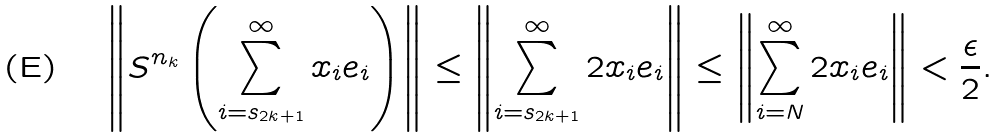Convert formula to latex. <formula><loc_0><loc_0><loc_500><loc_500>\left \| S ^ { n _ { k } } \left ( \sum _ { i = s _ { 2 k + 1 } } ^ { \infty } x _ { i } e _ { i } \right ) \right \| \leq \left \| \sum _ { i = s _ { 2 k + 1 } } ^ { \infty } 2 x _ { i } e _ { i } \right \| \leq \left \| \sum _ { i = N } ^ { \infty } 2 x _ { i } e _ { i } \right \| < \frac { \epsilon } { 2 } .</formula> 